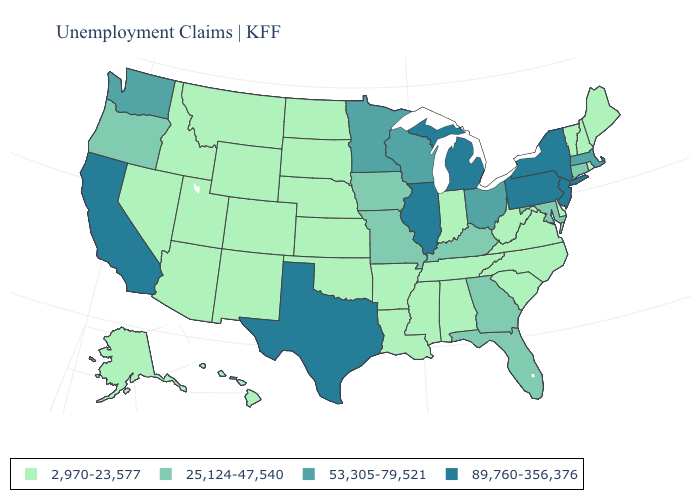Does the first symbol in the legend represent the smallest category?
Short answer required. Yes. What is the value of South Carolina?
Short answer required. 2,970-23,577. Does South Dakota have a lower value than Arizona?
Give a very brief answer. No. Name the states that have a value in the range 53,305-79,521?
Answer briefly. Massachusetts, Minnesota, Ohio, Washington, Wisconsin. What is the lowest value in the Northeast?
Short answer required. 2,970-23,577. Does Kansas have the highest value in the USA?
Give a very brief answer. No. Is the legend a continuous bar?
Answer briefly. No. What is the value of Arizona?
Quick response, please. 2,970-23,577. Name the states that have a value in the range 53,305-79,521?
Keep it brief. Massachusetts, Minnesota, Ohio, Washington, Wisconsin. What is the lowest value in the West?
Answer briefly. 2,970-23,577. Does Pennsylvania have the lowest value in the Northeast?
Write a very short answer. No. What is the lowest value in the Northeast?
Answer briefly. 2,970-23,577. What is the value of Georgia?
Give a very brief answer. 25,124-47,540. Name the states that have a value in the range 2,970-23,577?
Be succinct. Alabama, Alaska, Arizona, Arkansas, Colorado, Delaware, Hawaii, Idaho, Indiana, Kansas, Louisiana, Maine, Mississippi, Montana, Nebraska, Nevada, New Hampshire, New Mexico, North Carolina, North Dakota, Oklahoma, Rhode Island, South Carolina, South Dakota, Tennessee, Utah, Vermont, Virginia, West Virginia, Wyoming. How many symbols are there in the legend?
Write a very short answer. 4. 